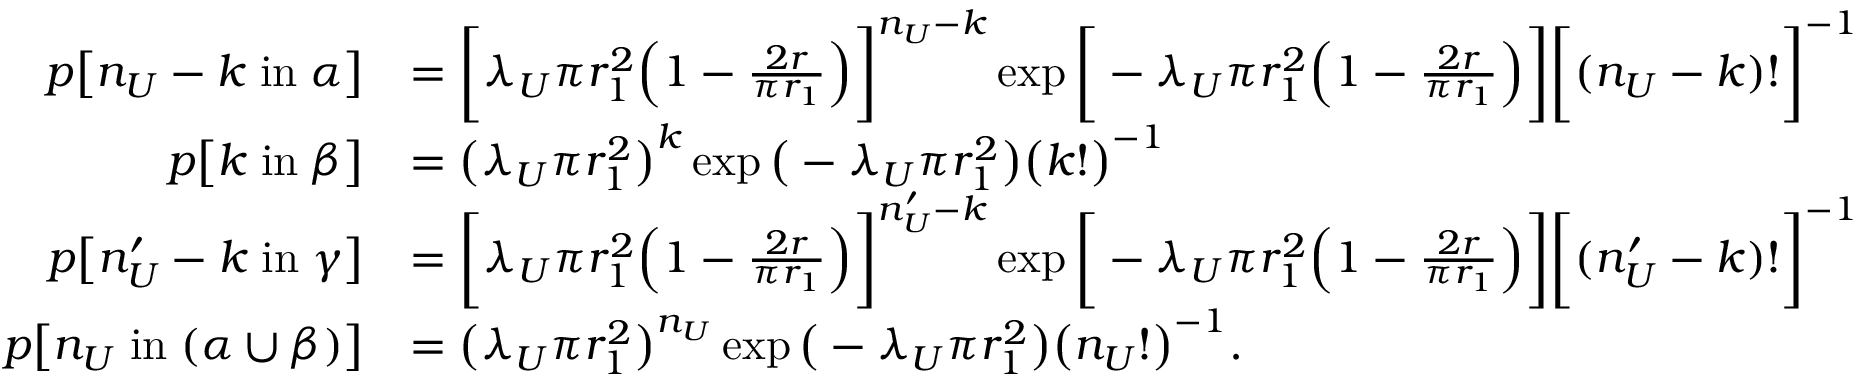Convert formula to latex. <formula><loc_0><loc_0><loc_500><loc_500>\begin{array} { r l } { p \left [ n _ { U } - k \, i n \, \alpha \right ] } & { = \left [ \lambda _ { U } \pi r _ { 1 } ^ { 2 } \left ( 1 - \frac { 2 r } { \pi r _ { 1 } } \right ) \right ] ^ { n _ { U } - k } \exp \left [ - \lambda _ { U } \pi r _ { 1 } ^ { 2 } \left ( 1 - \frac { 2 r } { \pi r _ { 1 } } \right ) \right ] \left [ ( n _ { U } - k ) ! \right ] ^ { - 1 } } \\ { p \left [ k \, i n \, \beta \right ] } & { = \left ( \lambda _ { U } \pi r _ { 1 } ^ { 2 } \right ) ^ { k } \exp \left ( - \lambda _ { U } \pi r _ { 1 } ^ { 2 } \right ) \left ( k ! \right ) ^ { - 1 } } \\ { p \left [ n _ { U } ^ { \prime } - k \, i n \, \gamma \right ] } & { = \left [ \lambda _ { U } \pi r _ { 1 } ^ { 2 } \left ( 1 - \frac { 2 r } { \pi r _ { 1 } } \right ) \right ] ^ { n _ { U } ^ { \prime } - k } \exp \left [ - \lambda _ { U } \pi r _ { 1 } ^ { 2 } \left ( 1 - \frac { 2 r } { \pi r _ { 1 } } \right ) \right ] \left [ ( n _ { U } ^ { \prime } - k ) ! \right ] ^ { - 1 } } \\ { p \left [ n _ { U } \, i n \, ( \alpha \cup \beta ) \right ] } & { = \left ( \lambda _ { U } \pi r _ { 1 } ^ { 2 } \right ) ^ { n _ { U } } \exp \left ( - \lambda _ { U } \pi r _ { 1 } ^ { 2 } \right ) \left ( n _ { U } ! \right ) ^ { - 1 } . } \end{array}</formula> 